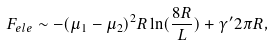<formula> <loc_0><loc_0><loc_500><loc_500>F _ { e l e } \sim - ( \mu _ { 1 } - \mu _ { 2 } ) ^ { 2 } R \ln ( \frac { 8 R } { L } ) + \gamma ^ { \prime } 2 \pi R ,</formula> 